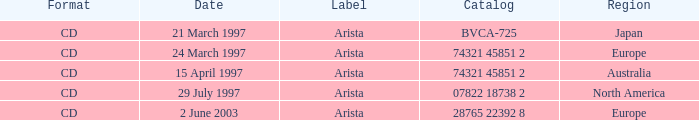What's listed for the Label with a Date of 29 July 1997? Arista. 